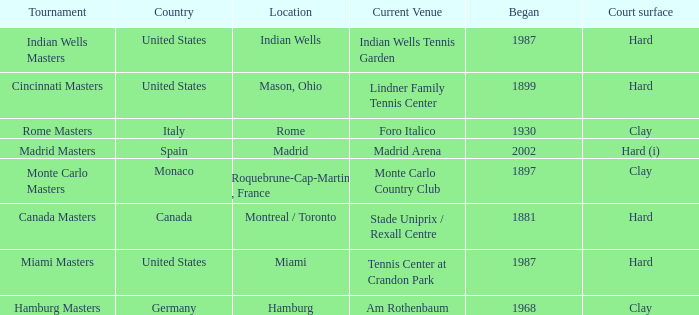What is the current venue for the Miami Masters tournament? Tennis Center at Crandon Park. 